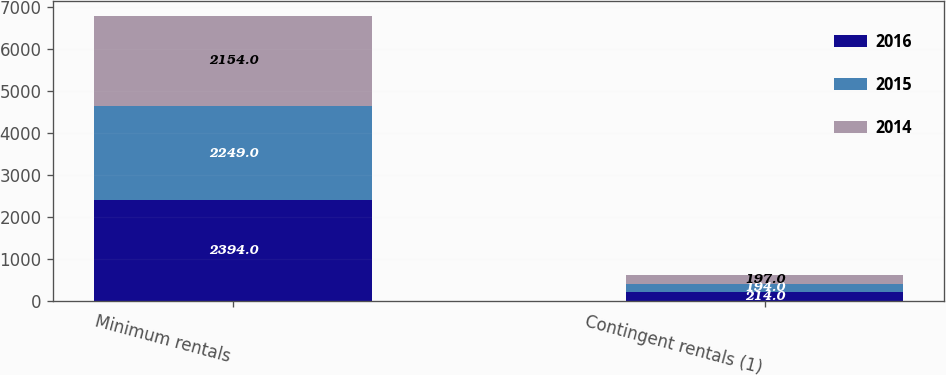<chart> <loc_0><loc_0><loc_500><loc_500><stacked_bar_chart><ecel><fcel>Minimum rentals<fcel>Contingent rentals (1)<nl><fcel>2016<fcel>2394<fcel>214<nl><fcel>2015<fcel>2249<fcel>194<nl><fcel>2014<fcel>2154<fcel>197<nl></chart> 